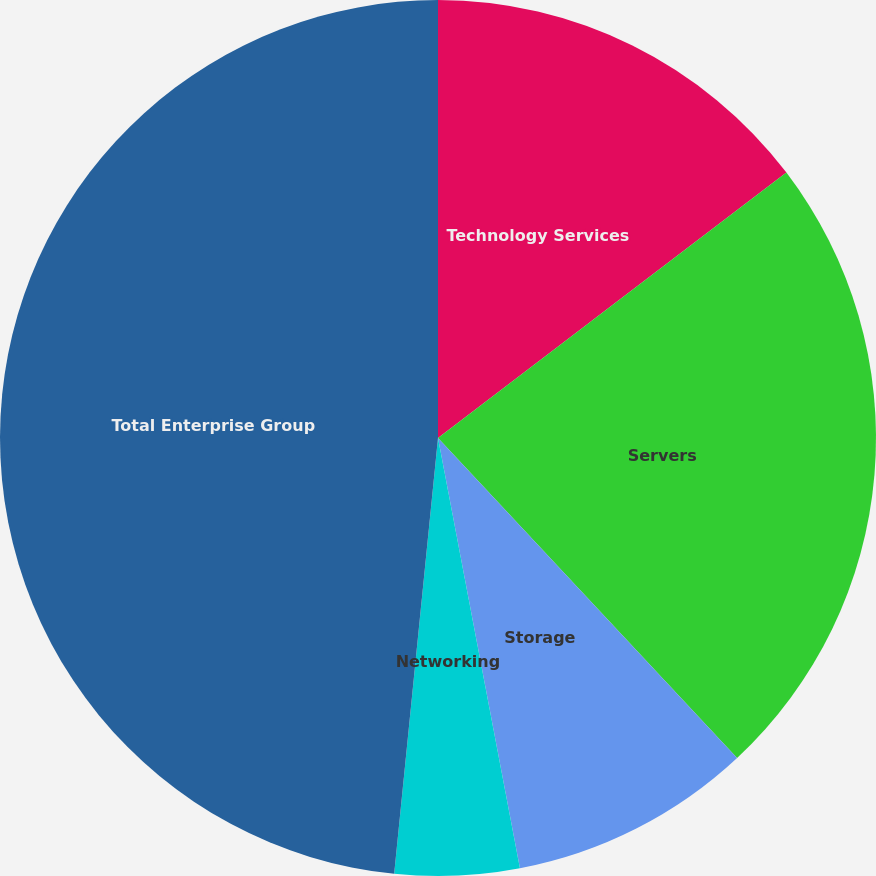Convert chart to OTSL. <chart><loc_0><loc_0><loc_500><loc_500><pie_chart><fcel>Technology Services<fcel>Servers<fcel>Storage<fcel>Networking<fcel>Total Enterprise Group<nl><fcel>14.64%<fcel>23.4%<fcel>8.97%<fcel>4.59%<fcel>48.41%<nl></chart> 